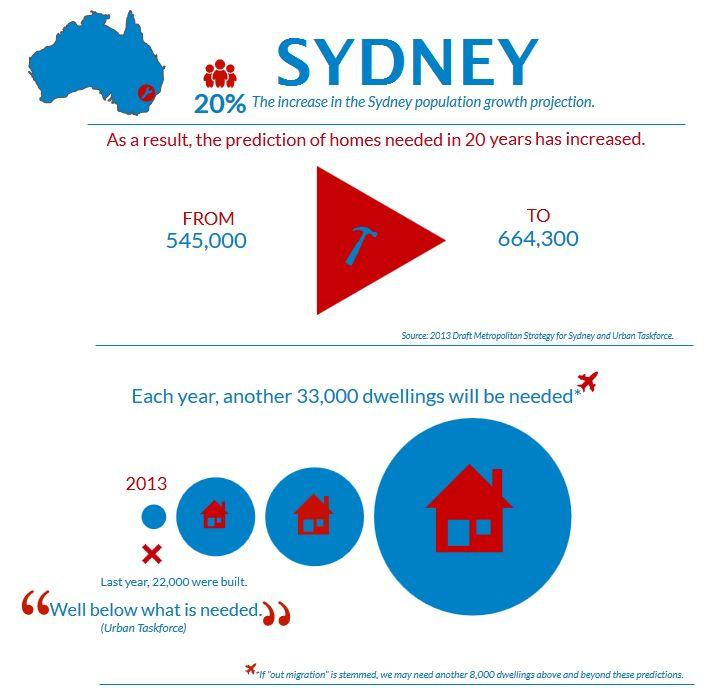Identify some key points in this picture. The prediction of the number of homes needed in 20 years is 119,300. 